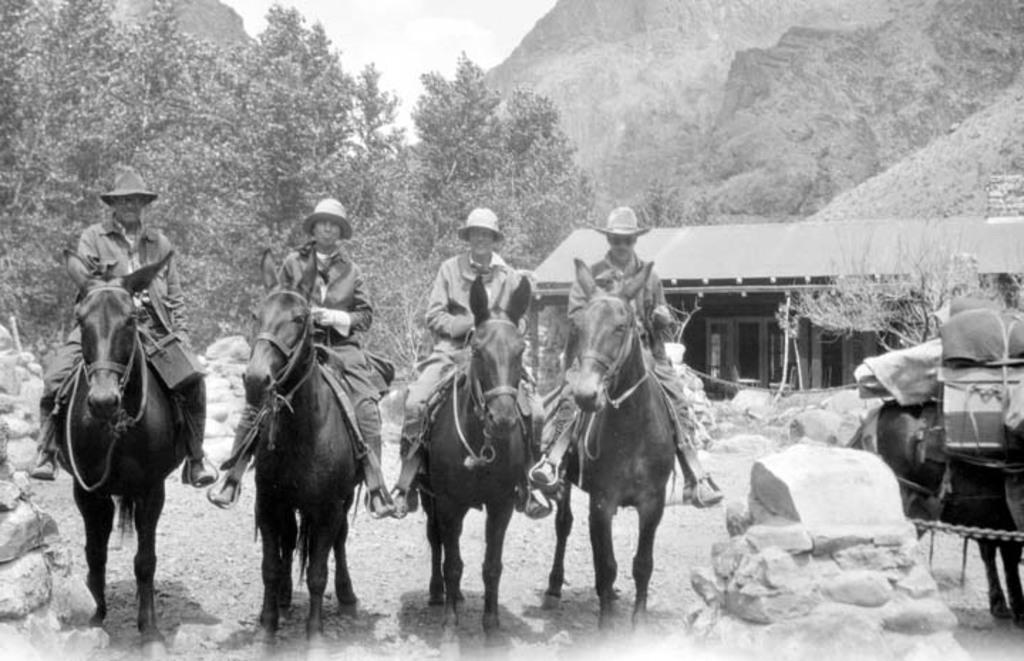Can you describe this image briefly? In this image I can see four persons are sitting on the horse and a horse cart. In the background I can see trees, houses, mountains and the sky. This image is taken may be during a day. 